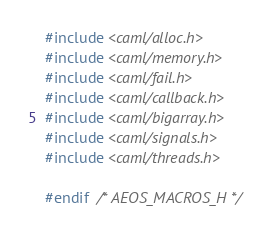Convert code to text. <code><loc_0><loc_0><loc_500><loc_500><_C_>#include <caml/alloc.h>
#include <caml/memory.h>
#include <caml/fail.h>
#include <caml/callback.h>
#include <caml/bigarray.h>
#include <caml/signals.h>
#include <caml/threads.h>

#endif  /* AEOS_MACROS_H */
</code> 